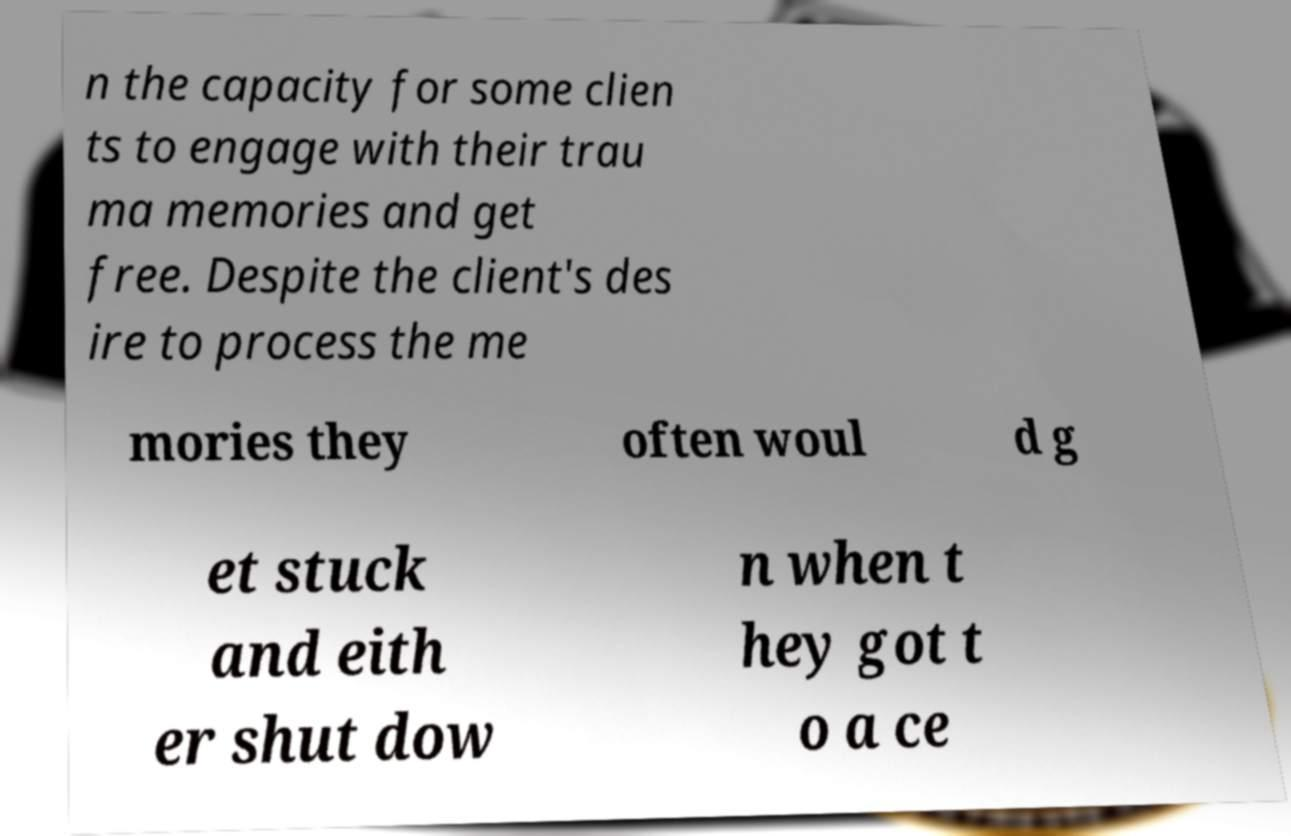Can you read and provide the text displayed in the image?This photo seems to have some interesting text. Can you extract and type it out for me? n the capacity for some clien ts to engage with their trau ma memories and get free. Despite the client's des ire to process the me mories they often woul d g et stuck and eith er shut dow n when t hey got t o a ce 